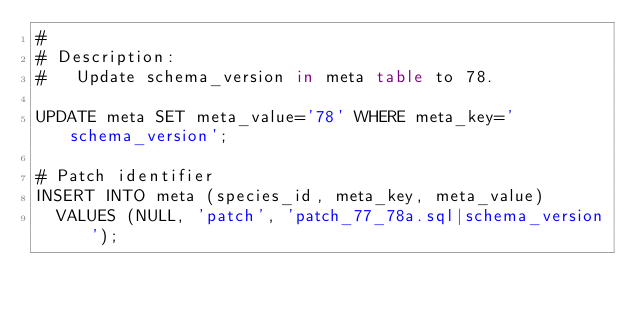<code> <loc_0><loc_0><loc_500><loc_500><_SQL_>#
# Description:
#   Update schema_version in meta table to 78.

UPDATE meta SET meta_value='78' WHERE meta_key='schema_version';

# Patch identifier
INSERT INTO meta (species_id, meta_key, meta_value)
  VALUES (NULL, 'patch', 'patch_77_78a.sql|schema_version');
</code> 